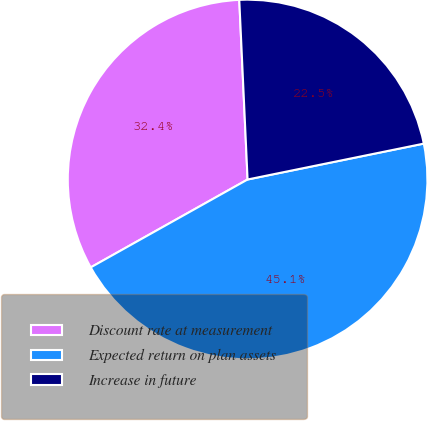<chart> <loc_0><loc_0><loc_500><loc_500><pie_chart><fcel>Discount rate at measurement<fcel>Expected return on plan assets<fcel>Increase in future<nl><fcel>32.39%<fcel>45.07%<fcel>22.54%<nl></chart> 